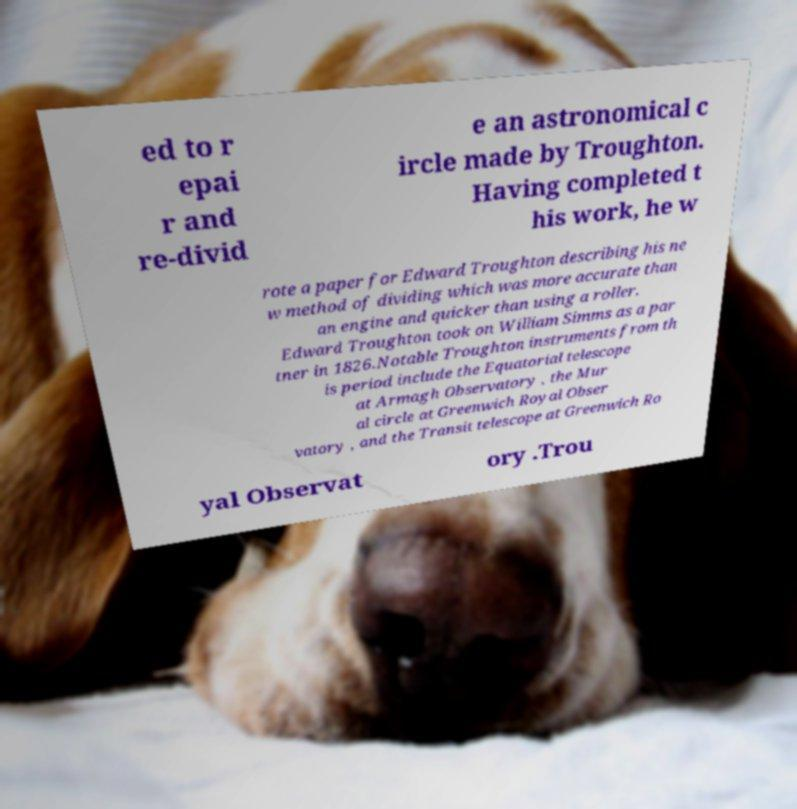Can you read and provide the text displayed in the image?This photo seems to have some interesting text. Can you extract and type it out for me? ed to r epai r and re-divid e an astronomical c ircle made by Troughton. Having completed t his work, he w rote a paper for Edward Troughton describing his ne w method of dividing which was more accurate than an engine and quicker than using a roller. Edward Troughton took on William Simms as a par tner in 1826.Notable Troughton instruments from th is period include the Equatorial telescope at Armagh Observatory , the Mur al circle at Greenwich Royal Obser vatory , and the Transit telescope at Greenwich Ro yal Observat ory .Trou 